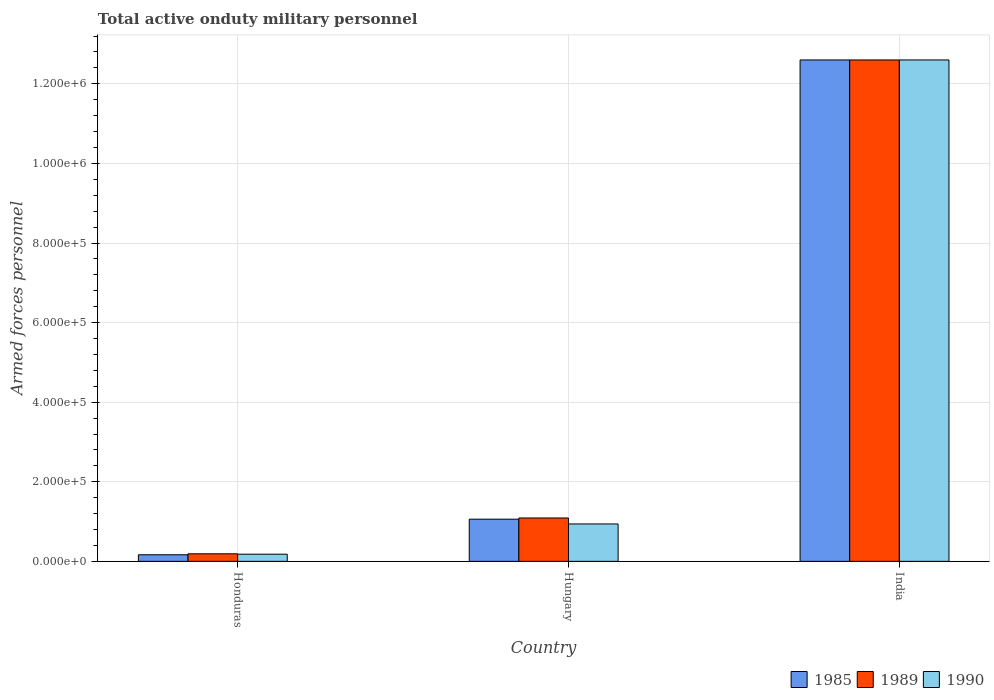How many groups of bars are there?
Your answer should be compact. 3. Are the number of bars per tick equal to the number of legend labels?
Provide a succinct answer. Yes. Are the number of bars on each tick of the X-axis equal?
Offer a very short reply. Yes. How many bars are there on the 2nd tick from the left?
Your answer should be very brief. 3. What is the label of the 1st group of bars from the left?
Offer a terse response. Honduras. What is the number of armed forces personnel in 1990 in Hungary?
Your response must be concise. 9.40e+04. Across all countries, what is the maximum number of armed forces personnel in 1989?
Make the answer very short. 1.26e+06. Across all countries, what is the minimum number of armed forces personnel in 1989?
Keep it short and to the point. 1.90e+04. In which country was the number of armed forces personnel in 1985 minimum?
Give a very brief answer. Honduras. What is the total number of armed forces personnel in 1989 in the graph?
Make the answer very short. 1.39e+06. What is the difference between the number of armed forces personnel in 1989 in Hungary and that in India?
Ensure brevity in your answer.  -1.15e+06. What is the difference between the number of armed forces personnel in 1989 in India and the number of armed forces personnel in 1985 in Hungary?
Offer a terse response. 1.15e+06. What is the average number of armed forces personnel in 1985 per country?
Keep it short and to the point. 4.61e+05. What is the difference between the number of armed forces personnel of/in 1985 and number of armed forces personnel of/in 1990 in Honduras?
Ensure brevity in your answer.  -1400. In how many countries, is the number of armed forces personnel in 1985 greater than 1040000?
Your answer should be compact. 1. What is the ratio of the number of armed forces personnel in 1985 in Honduras to that in India?
Your answer should be very brief. 0.01. What is the difference between the highest and the second highest number of armed forces personnel in 1985?
Offer a terse response. 1.15e+06. What is the difference between the highest and the lowest number of armed forces personnel in 1985?
Your answer should be compact. 1.24e+06. What does the 2nd bar from the right in Honduras represents?
Your answer should be compact. 1989. How many bars are there?
Your answer should be very brief. 9. How many countries are there in the graph?
Provide a short and direct response. 3. What is the difference between two consecutive major ticks on the Y-axis?
Give a very brief answer. 2.00e+05. Does the graph contain grids?
Ensure brevity in your answer.  Yes. How many legend labels are there?
Keep it short and to the point. 3. What is the title of the graph?
Your response must be concise. Total active onduty military personnel. Does "2002" appear as one of the legend labels in the graph?
Your answer should be very brief. No. What is the label or title of the Y-axis?
Your response must be concise. Armed forces personnel. What is the Armed forces personnel of 1985 in Honduras?
Ensure brevity in your answer.  1.66e+04. What is the Armed forces personnel of 1989 in Honduras?
Keep it short and to the point. 1.90e+04. What is the Armed forces personnel in 1990 in Honduras?
Keep it short and to the point. 1.80e+04. What is the Armed forces personnel of 1985 in Hungary?
Make the answer very short. 1.06e+05. What is the Armed forces personnel in 1989 in Hungary?
Your answer should be compact. 1.09e+05. What is the Armed forces personnel of 1990 in Hungary?
Your response must be concise. 9.40e+04. What is the Armed forces personnel in 1985 in India?
Offer a terse response. 1.26e+06. What is the Armed forces personnel of 1989 in India?
Your response must be concise. 1.26e+06. What is the Armed forces personnel of 1990 in India?
Offer a terse response. 1.26e+06. Across all countries, what is the maximum Armed forces personnel of 1985?
Give a very brief answer. 1.26e+06. Across all countries, what is the maximum Armed forces personnel in 1989?
Provide a succinct answer. 1.26e+06. Across all countries, what is the maximum Armed forces personnel of 1990?
Make the answer very short. 1.26e+06. Across all countries, what is the minimum Armed forces personnel of 1985?
Give a very brief answer. 1.66e+04. Across all countries, what is the minimum Armed forces personnel in 1989?
Provide a succinct answer. 1.90e+04. Across all countries, what is the minimum Armed forces personnel in 1990?
Keep it short and to the point. 1.80e+04. What is the total Armed forces personnel in 1985 in the graph?
Keep it short and to the point. 1.38e+06. What is the total Armed forces personnel in 1989 in the graph?
Give a very brief answer. 1.39e+06. What is the total Armed forces personnel in 1990 in the graph?
Your answer should be very brief. 1.37e+06. What is the difference between the Armed forces personnel of 1985 in Honduras and that in Hungary?
Offer a very short reply. -8.94e+04. What is the difference between the Armed forces personnel in 1990 in Honduras and that in Hungary?
Ensure brevity in your answer.  -7.60e+04. What is the difference between the Armed forces personnel in 1985 in Honduras and that in India?
Keep it short and to the point. -1.24e+06. What is the difference between the Armed forces personnel in 1989 in Honduras and that in India?
Keep it short and to the point. -1.24e+06. What is the difference between the Armed forces personnel in 1990 in Honduras and that in India?
Give a very brief answer. -1.24e+06. What is the difference between the Armed forces personnel of 1985 in Hungary and that in India?
Your answer should be very brief. -1.15e+06. What is the difference between the Armed forces personnel of 1989 in Hungary and that in India?
Provide a short and direct response. -1.15e+06. What is the difference between the Armed forces personnel in 1990 in Hungary and that in India?
Offer a terse response. -1.17e+06. What is the difference between the Armed forces personnel in 1985 in Honduras and the Armed forces personnel in 1989 in Hungary?
Offer a very short reply. -9.24e+04. What is the difference between the Armed forces personnel of 1985 in Honduras and the Armed forces personnel of 1990 in Hungary?
Provide a short and direct response. -7.74e+04. What is the difference between the Armed forces personnel of 1989 in Honduras and the Armed forces personnel of 1990 in Hungary?
Offer a terse response. -7.50e+04. What is the difference between the Armed forces personnel of 1985 in Honduras and the Armed forces personnel of 1989 in India?
Your answer should be compact. -1.24e+06. What is the difference between the Armed forces personnel of 1985 in Honduras and the Armed forces personnel of 1990 in India?
Your answer should be compact. -1.24e+06. What is the difference between the Armed forces personnel of 1989 in Honduras and the Armed forces personnel of 1990 in India?
Offer a very short reply. -1.24e+06. What is the difference between the Armed forces personnel in 1985 in Hungary and the Armed forces personnel in 1989 in India?
Provide a short and direct response. -1.15e+06. What is the difference between the Armed forces personnel of 1985 in Hungary and the Armed forces personnel of 1990 in India?
Your response must be concise. -1.15e+06. What is the difference between the Armed forces personnel in 1989 in Hungary and the Armed forces personnel in 1990 in India?
Keep it short and to the point. -1.15e+06. What is the average Armed forces personnel of 1985 per country?
Offer a terse response. 4.61e+05. What is the average Armed forces personnel of 1989 per country?
Give a very brief answer. 4.63e+05. What is the average Armed forces personnel in 1990 per country?
Provide a short and direct response. 4.57e+05. What is the difference between the Armed forces personnel of 1985 and Armed forces personnel of 1989 in Honduras?
Offer a very short reply. -2400. What is the difference between the Armed forces personnel in 1985 and Armed forces personnel in 1990 in Honduras?
Your answer should be very brief. -1400. What is the difference between the Armed forces personnel of 1985 and Armed forces personnel of 1989 in Hungary?
Your answer should be very brief. -3000. What is the difference between the Armed forces personnel of 1985 and Armed forces personnel of 1990 in Hungary?
Offer a very short reply. 1.20e+04. What is the difference between the Armed forces personnel of 1989 and Armed forces personnel of 1990 in Hungary?
Offer a very short reply. 1.50e+04. What is the ratio of the Armed forces personnel of 1985 in Honduras to that in Hungary?
Ensure brevity in your answer.  0.16. What is the ratio of the Armed forces personnel of 1989 in Honduras to that in Hungary?
Ensure brevity in your answer.  0.17. What is the ratio of the Armed forces personnel in 1990 in Honduras to that in Hungary?
Offer a very short reply. 0.19. What is the ratio of the Armed forces personnel in 1985 in Honduras to that in India?
Your response must be concise. 0.01. What is the ratio of the Armed forces personnel of 1989 in Honduras to that in India?
Provide a short and direct response. 0.02. What is the ratio of the Armed forces personnel of 1990 in Honduras to that in India?
Keep it short and to the point. 0.01. What is the ratio of the Armed forces personnel of 1985 in Hungary to that in India?
Make the answer very short. 0.08. What is the ratio of the Armed forces personnel in 1989 in Hungary to that in India?
Provide a short and direct response. 0.09. What is the ratio of the Armed forces personnel of 1990 in Hungary to that in India?
Offer a very short reply. 0.07. What is the difference between the highest and the second highest Armed forces personnel in 1985?
Provide a short and direct response. 1.15e+06. What is the difference between the highest and the second highest Armed forces personnel of 1989?
Your answer should be compact. 1.15e+06. What is the difference between the highest and the second highest Armed forces personnel of 1990?
Ensure brevity in your answer.  1.17e+06. What is the difference between the highest and the lowest Armed forces personnel in 1985?
Your answer should be compact. 1.24e+06. What is the difference between the highest and the lowest Armed forces personnel in 1989?
Your response must be concise. 1.24e+06. What is the difference between the highest and the lowest Armed forces personnel of 1990?
Your answer should be very brief. 1.24e+06. 